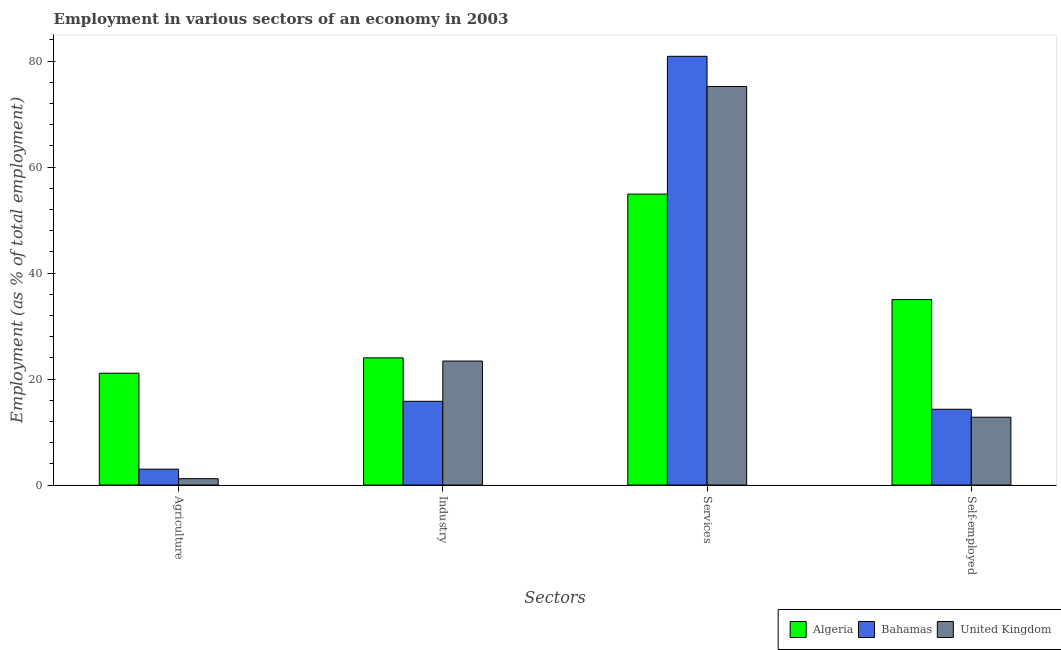How many different coloured bars are there?
Ensure brevity in your answer.  3. Are the number of bars per tick equal to the number of legend labels?
Keep it short and to the point. Yes. Are the number of bars on each tick of the X-axis equal?
Make the answer very short. Yes. How many bars are there on the 4th tick from the right?
Provide a short and direct response. 3. What is the label of the 1st group of bars from the left?
Provide a short and direct response. Agriculture. What is the percentage of workers in industry in Bahamas?
Your response must be concise. 15.8. Across all countries, what is the maximum percentage of self employed workers?
Keep it short and to the point. 35. Across all countries, what is the minimum percentage of self employed workers?
Your answer should be compact. 12.8. In which country was the percentage of workers in services maximum?
Your answer should be compact. Bahamas. What is the total percentage of workers in agriculture in the graph?
Your response must be concise. 25.3. What is the difference between the percentage of self employed workers in Algeria and the percentage of workers in agriculture in United Kingdom?
Provide a succinct answer. 33.8. What is the average percentage of workers in agriculture per country?
Make the answer very short. 8.43. What is the difference between the percentage of workers in agriculture and percentage of workers in industry in Algeria?
Your answer should be compact. -2.9. In how many countries, is the percentage of workers in services greater than 68 %?
Offer a very short reply. 2. What is the ratio of the percentage of workers in services in Algeria to that in Bahamas?
Provide a succinct answer. 0.68. Is the percentage of workers in agriculture in Algeria less than that in United Kingdom?
Make the answer very short. No. What is the difference between the highest and the second highest percentage of workers in industry?
Your response must be concise. 0.6. What is the difference between the highest and the lowest percentage of workers in industry?
Offer a very short reply. 8.2. In how many countries, is the percentage of workers in services greater than the average percentage of workers in services taken over all countries?
Your answer should be compact. 2. What does the 2nd bar from the right in Agriculture represents?
Provide a short and direct response. Bahamas. How many bars are there?
Your answer should be very brief. 12. Are all the bars in the graph horizontal?
Ensure brevity in your answer.  No. How many countries are there in the graph?
Offer a terse response. 3. Are the values on the major ticks of Y-axis written in scientific E-notation?
Provide a short and direct response. No. How are the legend labels stacked?
Ensure brevity in your answer.  Horizontal. What is the title of the graph?
Offer a very short reply. Employment in various sectors of an economy in 2003. What is the label or title of the X-axis?
Give a very brief answer. Sectors. What is the label or title of the Y-axis?
Make the answer very short. Employment (as % of total employment). What is the Employment (as % of total employment) of Algeria in Agriculture?
Ensure brevity in your answer.  21.1. What is the Employment (as % of total employment) in United Kingdom in Agriculture?
Provide a succinct answer. 1.2. What is the Employment (as % of total employment) in Bahamas in Industry?
Your response must be concise. 15.8. What is the Employment (as % of total employment) of United Kingdom in Industry?
Offer a very short reply. 23.4. What is the Employment (as % of total employment) in Algeria in Services?
Offer a very short reply. 54.9. What is the Employment (as % of total employment) of Bahamas in Services?
Your answer should be very brief. 80.9. What is the Employment (as % of total employment) of United Kingdom in Services?
Offer a very short reply. 75.2. What is the Employment (as % of total employment) of Bahamas in Self-employed?
Offer a terse response. 14.3. What is the Employment (as % of total employment) of United Kingdom in Self-employed?
Your answer should be compact. 12.8. Across all Sectors, what is the maximum Employment (as % of total employment) of Algeria?
Your response must be concise. 54.9. Across all Sectors, what is the maximum Employment (as % of total employment) in Bahamas?
Provide a succinct answer. 80.9. Across all Sectors, what is the maximum Employment (as % of total employment) in United Kingdom?
Your response must be concise. 75.2. Across all Sectors, what is the minimum Employment (as % of total employment) in Algeria?
Your answer should be compact. 21.1. Across all Sectors, what is the minimum Employment (as % of total employment) of Bahamas?
Offer a very short reply. 3. Across all Sectors, what is the minimum Employment (as % of total employment) of United Kingdom?
Keep it short and to the point. 1.2. What is the total Employment (as % of total employment) of Algeria in the graph?
Offer a terse response. 135. What is the total Employment (as % of total employment) in Bahamas in the graph?
Keep it short and to the point. 114. What is the total Employment (as % of total employment) of United Kingdom in the graph?
Offer a very short reply. 112.6. What is the difference between the Employment (as % of total employment) of Algeria in Agriculture and that in Industry?
Ensure brevity in your answer.  -2.9. What is the difference between the Employment (as % of total employment) of Bahamas in Agriculture and that in Industry?
Offer a very short reply. -12.8. What is the difference between the Employment (as % of total employment) of United Kingdom in Agriculture and that in Industry?
Give a very brief answer. -22.2. What is the difference between the Employment (as % of total employment) of Algeria in Agriculture and that in Services?
Keep it short and to the point. -33.8. What is the difference between the Employment (as % of total employment) in Bahamas in Agriculture and that in Services?
Provide a succinct answer. -77.9. What is the difference between the Employment (as % of total employment) in United Kingdom in Agriculture and that in Services?
Your response must be concise. -74. What is the difference between the Employment (as % of total employment) of Algeria in Agriculture and that in Self-employed?
Make the answer very short. -13.9. What is the difference between the Employment (as % of total employment) in Bahamas in Agriculture and that in Self-employed?
Provide a short and direct response. -11.3. What is the difference between the Employment (as % of total employment) in Algeria in Industry and that in Services?
Provide a short and direct response. -30.9. What is the difference between the Employment (as % of total employment) of Bahamas in Industry and that in Services?
Keep it short and to the point. -65.1. What is the difference between the Employment (as % of total employment) of United Kingdom in Industry and that in Services?
Offer a very short reply. -51.8. What is the difference between the Employment (as % of total employment) in Algeria in Industry and that in Self-employed?
Offer a terse response. -11. What is the difference between the Employment (as % of total employment) in Bahamas in Industry and that in Self-employed?
Your answer should be compact. 1.5. What is the difference between the Employment (as % of total employment) in United Kingdom in Industry and that in Self-employed?
Keep it short and to the point. 10.6. What is the difference between the Employment (as % of total employment) of Bahamas in Services and that in Self-employed?
Give a very brief answer. 66.6. What is the difference between the Employment (as % of total employment) in United Kingdom in Services and that in Self-employed?
Offer a terse response. 62.4. What is the difference between the Employment (as % of total employment) of Algeria in Agriculture and the Employment (as % of total employment) of Bahamas in Industry?
Your answer should be very brief. 5.3. What is the difference between the Employment (as % of total employment) of Algeria in Agriculture and the Employment (as % of total employment) of United Kingdom in Industry?
Offer a terse response. -2.3. What is the difference between the Employment (as % of total employment) of Bahamas in Agriculture and the Employment (as % of total employment) of United Kingdom in Industry?
Offer a terse response. -20.4. What is the difference between the Employment (as % of total employment) in Algeria in Agriculture and the Employment (as % of total employment) in Bahamas in Services?
Offer a very short reply. -59.8. What is the difference between the Employment (as % of total employment) in Algeria in Agriculture and the Employment (as % of total employment) in United Kingdom in Services?
Your answer should be compact. -54.1. What is the difference between the Employment (as % of total employment) of Bahamas in Agriculture and the Employment (as % of total employment) of United Kingdom in Services?
Make the answer very short. -72.2. What is the difference between the Employment (as % of total employment) of Algeria in Agriculture and the Employment (as % of total employment) of Bahamas in Self-employed?
Offer a very short reply. 6.8. What is the difference between the Employment (as % of total employment) in Algeria in Agriculture and the Employment (as % of total employment) in United Kingdom in Self-employed?
Your response must be concise. 8.3. What is the difference between the Employment (as % of total employment) in Bahamas in Agriculture and the Employment (as % of total employment) in United Kingdom in Self-employed?
Your response must be concise. -9.8. What is the difference between the Employment (as % of total employment) of Algeria in Industry and the Employment (as % of total employment) of Bahamas in Services?
Ensure brevity in your answer.  -56.9. What is the difference between the Employment (as % of total employment) in Algeria in Industry and the Employment (as % of total employment) in United Kingdom in Services?
Your answer should be compact. -51.2. What is the difference between the Employment (as % of total employment) of Bahamas in Industry and the Employment (as % of total employment) of United Kingdom in Services?
Ensure brevity in your answer.  -59.4. What is the difference between the Employment (as % of total employment) in Algeria in Industry and the Employment (as % of total employment) in United Kingdom in Self-employed?
Provide a succinct answer. 11.2. What is the difference between the Employment (as % of total employment) of Algeria in Services and the Employment (as % of total employment) of Bahamas in Self-employed?
Give a very brief answer. 40.6. What is the difference between the Employment (as % of total employment) of Algeria in Services and the Employment (as % of total employment) of United Kingdom in Self-employed?
Your answer should be very brief. 42.1. What is the difference between the Employment (as % of total employment) in Bahamas in Services and the Employment (as % of total employment) in United Kingdom in Self-employed?
Offer a terse response. 68.1. What is the average Employment (as % of total employment) of Algeria per Sectors?
Give a very brief answer. 33.75. What is the average Employment (as % of total employment) in Bahamas per Sectors?
Your answer should be compact. 28.5. What is the average Employment (as % of total employment) in United Kingdom per Sectors?
Provide a short and direct response. 28.15. What is the difference between the Employment (as % of total employment) in Bahamas and Employment (as % of total employment) in United Kingdom in Agriculture?
Your answer should be very brief. 1.8. What is the difference between the Employment (as % of total employment) in Algeria and Employment (as % of total employment) in United Kingdom in Industry?
Make the answer very short. 0.6. What is the difference between the Employment (as % of total employment) of Bahamas and Employment (as % of total employment) of United Kingdom in Industry?
Offer a very short reply. -7.6. What is the difference between the Employment (as % of total employment) in Algeria and Employment (as % of total employment) in Bahamas in Services?
Offer a very short reply. -26. What is the difference between the Employment (as % of total employment) in Algeria and Employment (as % of total employment) in United Kingdom in Services?
Provide a short and direct response. -20.3. What is the difference between the Employment (as % of total employment) in Algeria and Employment (as % of total employment) in Bahamas in Self-employed?
Offer a terse response. 20.7. What is the ratio of the Employment (as % of total employment) in Algeria in Agriculture to that in Industry?
Ensure brevity in your answer.  0.88. What is the ratio of the Employment (as % of total employment) of Bahamas in Agriculture to that in Industry?
Your response must be concise. 0.19. What is the ratio of the Employment (as % of total employment) of United Kingdom in Agriculture to that in Industry?
Give a very brief answer. 0.05. What is the ratio of the Employment (as % of total employment) of Algeria in Agriculture to that in Services?
Give a very brief answer. 0.38. What is the ratio of the Employment (as % of total employment) of Bahamas in Agriculture to that in Services?
Offer a very short reply. 0.04. What is the ratio of the Employment (as % of total employment) in United Kingdom in Agriculture to that in Services?
Provide a succinct answer. 0.02. What is the ratio of the Employment (as % of total employment) of Algeria in Agriculture to that in Self-employed?
Give a very brief answer. 0.6. What is the ratio of the Employment (as % of total employment) of Bahamas in Agriculture to that in Self-employed?
Give a very brief answer. 0.21. What is the ratio of the Employment (as % of total employment) in United Kingdom in Agriculture to that in Self-employed?
Your response must be concise. 0.09. What is the ratio of the Employment (as % of total employment) of Algeria in Industry to that in Services?
Keep it short and to the point. 0.44. What is the ratio of the Employment (as % of total employment) of Bahamas in Industry to that in Services?
Offer a terse response. 0.2. What is the ratio of the Employment (as % of total employment) in United Kingdom in Industry to that in Services?
Keep it short and to the point. 0.31. What is the ratio of the Employment (as % of total employment) of Algeria in Industry to that in Self-employed?
Your response must be concise. 0.69. What is the ratio of the Employment (as % of total employment) in Bahamas in Industry to that in Self-employed?
Ensure brevity in your answer.  1.1. What is the ratio of the Employment (as % of total employment) of United Kingdom in Industry to that in Self-employed?
Your answer should be compact. 1.83. What is the ratio of the Employment (as % of total employment) in Algeria in Services to that in Self-employed?
Offer a very short reply. 1.57. What is the ratio of the Employment (as % of total employment) in Bahamas in Services to that in Self-employed?
Your answer should be compact. 5.66. What is the ratio of the Employment (as % of total employment) in United Kingdom in Services to that in Self-employed?
Provide a succinct answer. 5.88. What is the difference between the highest and the second highest Employment (as % of total employment) of Algeria?
Your response must be concise. 19.9. What is the difference between the highest and the second highest Employment (as % of total employment) of Bahamas?
Offer a terse response. 65.1. What is the difference between the highest and the second highest Employment (as % of total employment) of United Kingdom?
Offer a terse response. 51.8. What is the difference between the highest and the lowest Employment (as % of total employment) in Algeria?
Keep it short and to the point. 33.8. What is the difference between the highest and the lowest Employment (as % of total employment) in Bahamas?
Offer a very short reply. 77.9. What is the difference between the highest and the lowest Employment (as % of total employment) of United Kingdom?
Offer a terse response. 74. 